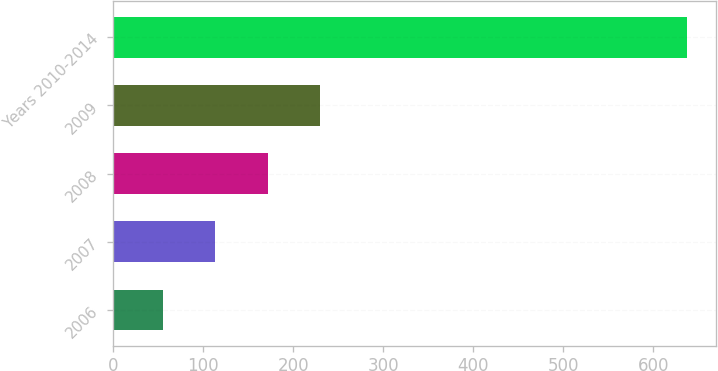Convert chart to OTSL. <chart><loc_0><loc_0><loc_500><loc_500><bar_chart><fcel>2006<fcel>2007<fcel>2008<fcel>2009<fcel>Years 2010-2014<nl><fcel>55<fcel>113.3<fcel>171.6<fcel>229.9<fcel>638<nl></chart> 